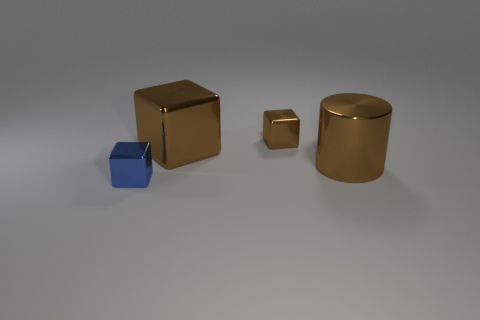Add 3 tiny blue shiny blocks. How many objects exist? 7 Subtract all cylinders. How many objects are left? 3 Add 2 tiny brown rubber balls. How many tiny brown rubber balls exist? 2 Subtract 0 cyan cylinders. How many objects are left? 4 Subtract all large red objects. Subtract all brown blocks. How many objects are left? 2 Add 3 brown shiny things. How many brown shiny things are left? 6 